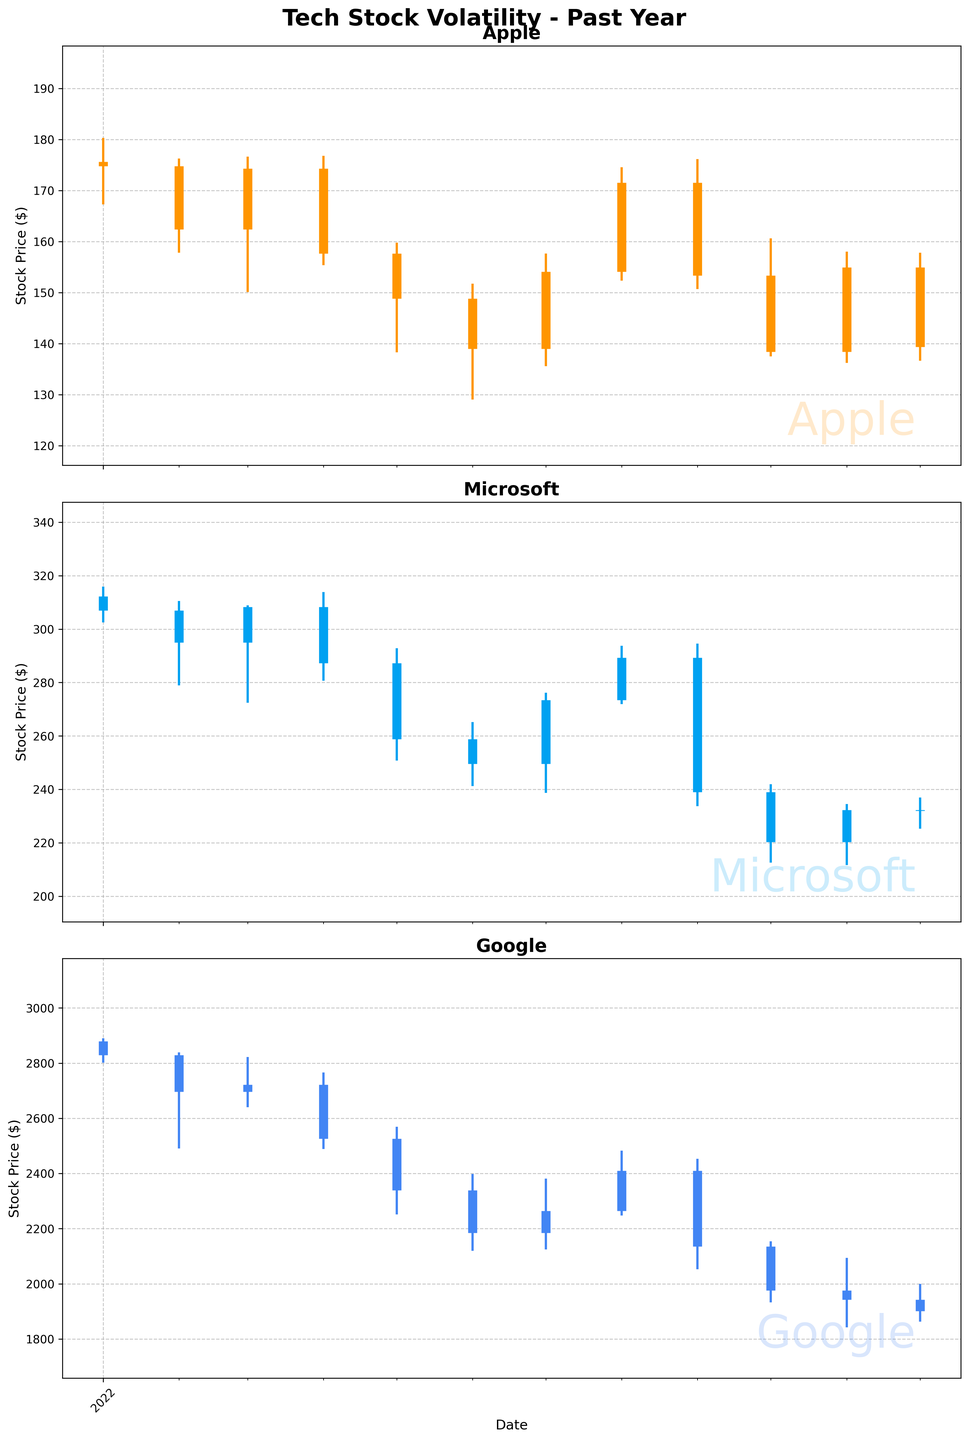When did Apple experience its highest high in the past year? Checking the candlestick plot for Apple, the highest high is marked in January 2022. The candle representing January has the highest vertical line.
Answer: January 2022 Which company had the largest range in stock price in February 2022? Look at the lengths of the vertical lines for February 2022 across all three companies. Google's candlestick has the longest line, representing a large difference between its high and low prices.
Answer: Google What month did Microsoft close at its highest price? Observing the thick vertical bars for Microsoft, the highest closing price occurs in March 2022. The top of the thick bar in March seems to be the highest point across all months.
Answer: March 2022 Compare Apple's stock price volatility in February with that in June. Which month had higher volatility? For volatility, we consider the range between the high and low prices. The February candlestick has a longer vertical line compared to June, indicating higher volatility.
Answer: February How did Google's stock price trend from May to July? Reviewing the sequence of candlesticks from May to July, Google's opening and closing prices show a trend where the stock initially drops in May and June but starts to rise again in July.
Answer: It dropped initially and then rose Which month recorded the lowest closing price for Microsoft? Reviewing the bottom of the thick vertical bars for Microsoft, it appears that the lowest closing price is in October 2022. The bottom end of the thick bar in October is the lowest among all months.
Answer: October 2022 What is the average closing price for Apple across the entire year? To find the average, sum up the closing prices for Apple from all months and divide by the number of months (12). Sum = 162.41 + 174.31 + 157.65 + 148.84 + 138.98 + 154.09 + 171.52 + 153.34+ 138.38+ 154.94+ 139.37+ 174.78. Average = Sum/12
Answer: $155.68 Did any company show consistent growth in closing prices for more consecutive months? Observing the candlestick trends for all companies, none of the three companies show consistent growth in closing prices for more than two consecutive months. Each has fluctuations.
Answer: No Which company had the least overall stock price volatility in the examined period? By checking the lengths of the vertical lines (highs minus lows) for each company, Microsoft seems to have the shortest overall lines compared to Apple and Google, indicating the least volatility.
Answer: Microsoft When did Google experience the lowest monthly closing price? For Google, examining the bottom tips of the thick vertical bars, December 2022 has the lowest monthly closing price. The bar in December is the shortest.
Answer: December 2022 